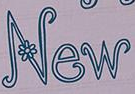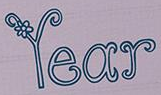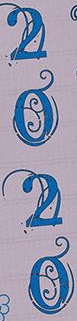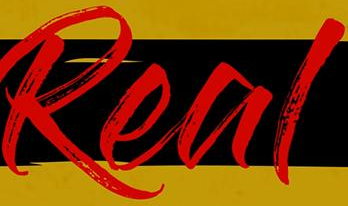What words can you see in these images in sequence, separated by a semicolon? New; Year; 2020; Real 